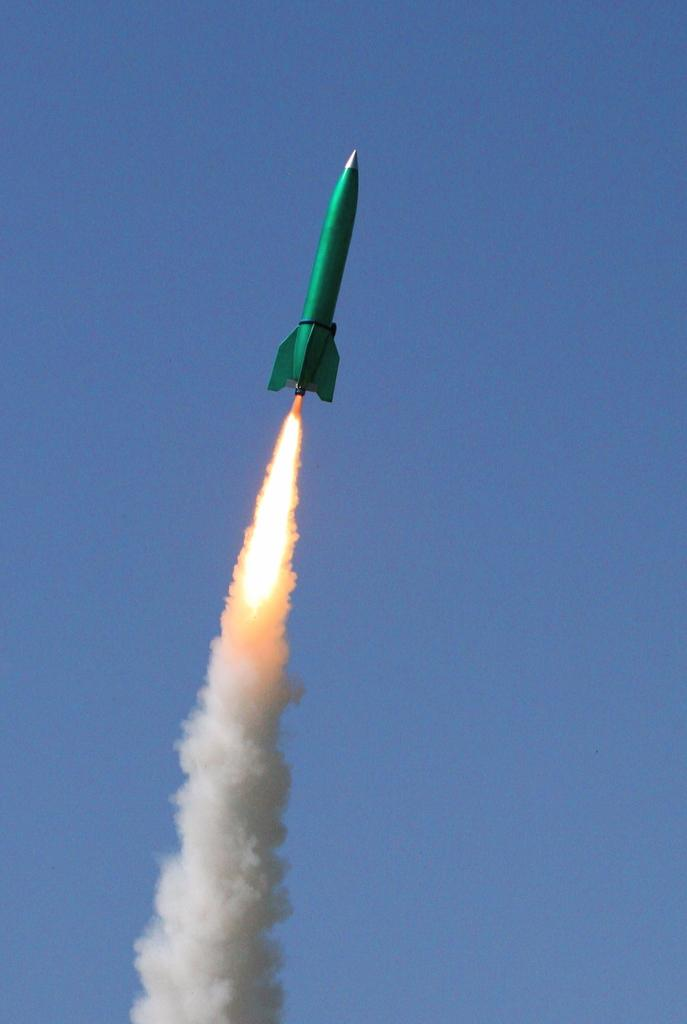What is the color of the rocket in the image? The rocket is green in the image. Where is the rocket located in the image? The rocket is in the air in the image. What can be seen coming out of the rocket? White color smoke is coming out of the rocket in the image. What color is the sky in the background of the image? The sky in the background of the image is blue. Can you see a carriage being pulled by horses in the image? No, there is no carriage or horses present in the image. Is there a watch visible on the rocket in the image? No, there is no watch visible on the rocket in the image. 